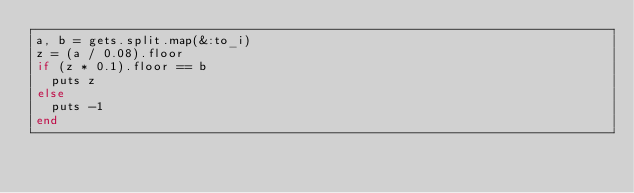Convert code to text. <code><loc_0><loc_0><loc_500><loc_500><_Ruby_>a, b = gets.split.map(&:to_i)
z = (a / 0.08).floor
if (z * 0.1).floor == b
  puts z
else
  puts -1
end</code> 